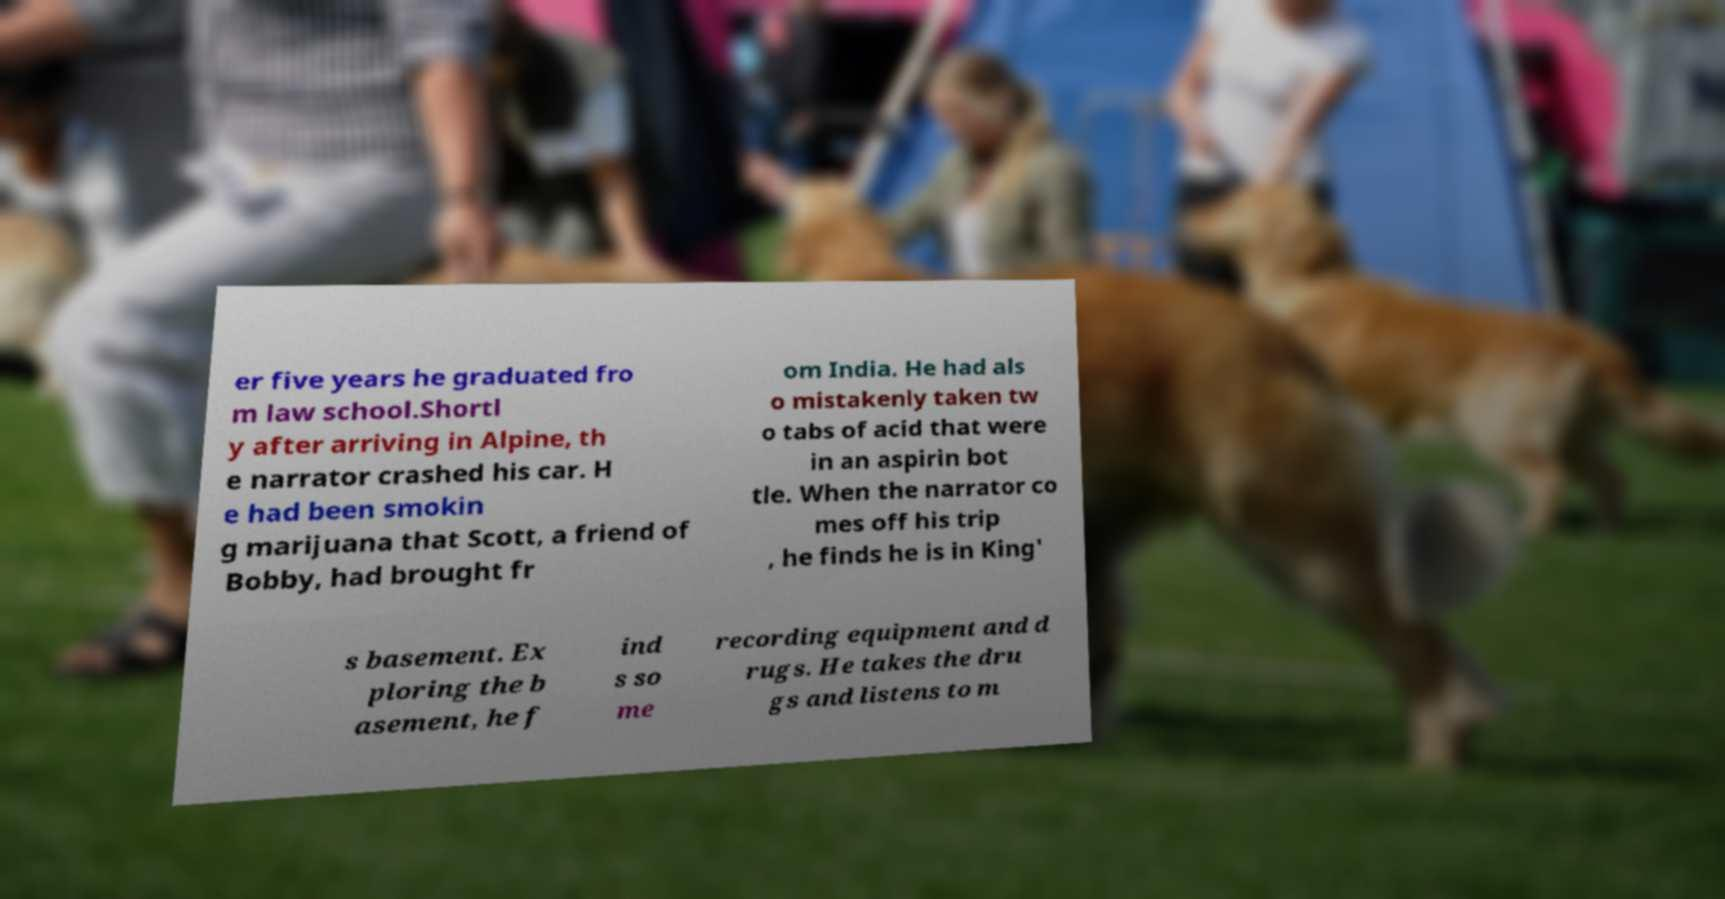Could you assist in decoding the text presented in this image and type it out clearly? er five years he graduated fro m law school.Shortl y after arriving in Alpine, th e narrator crashed his car. H e had been smokin g marijuana that Scott, a friend of Bobby, had brought fr om India. He had als o mistakenly taken tw o tabs of acid that were in an aspirin bot tle. When the narrator co mes off his trip , he finds he is in King' s basement. Ex ploring the b asement, he f ind s so me recording equipment and d rugs. He takes the dru gs and listens to m 